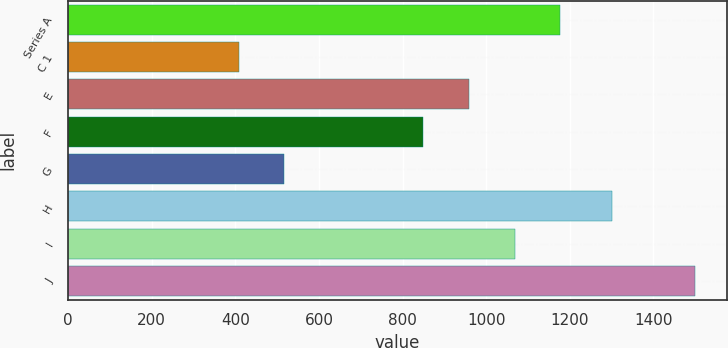<chart> <loc_0><loc_0><loc_500><loc_500><bar_chart><fcel>Series A<fcel>C 1<fcel>E<fcel>F<fcel>G<fcel>H<fcel>I<fcel>J<nl><fcel>1177.6<fcel>408<fcel>959.2<fcel>850<fcel>517.2<fcel>1300<fcel>1068.4<fcel>1500<nl></chart> 